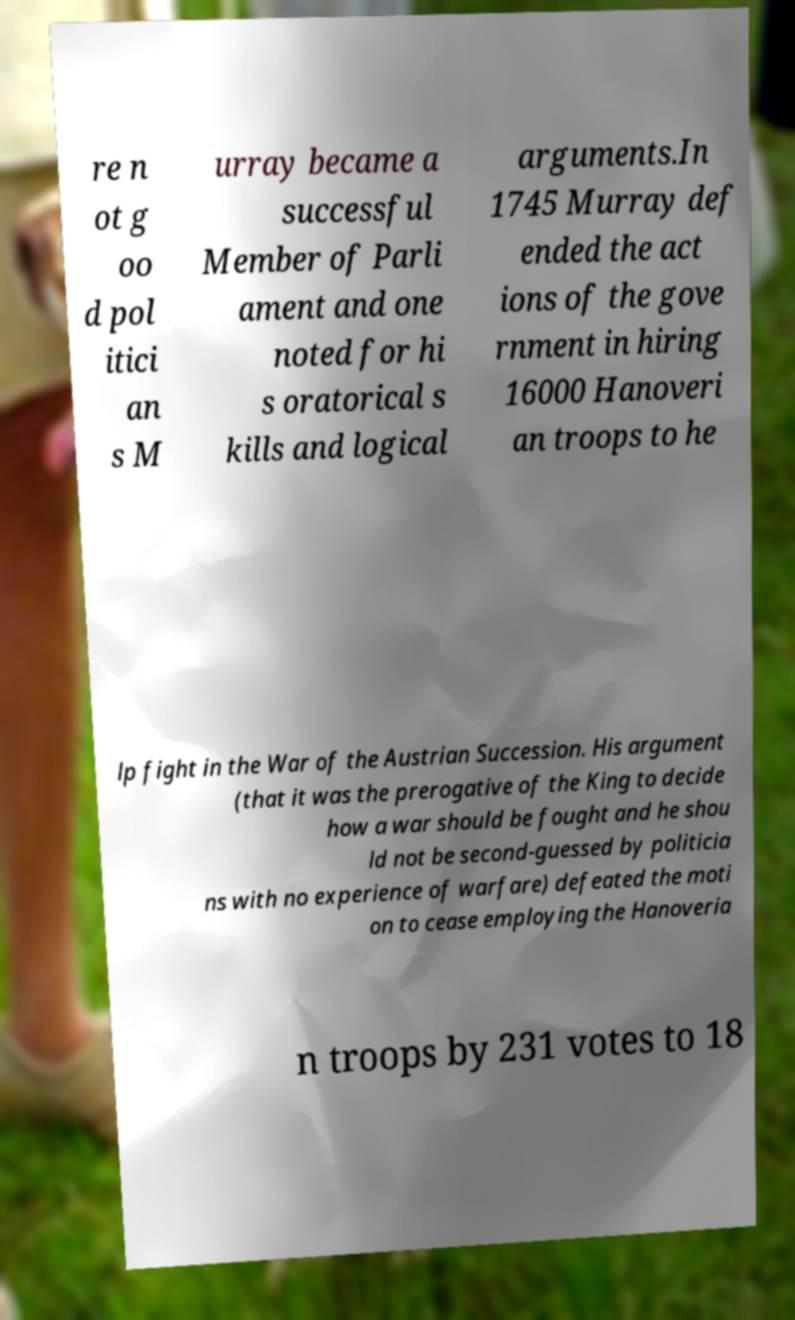There's text embedded in this image that I need extracted. Can you transcribe it verbatim? re n ot g oo d pol itici an s M urray became a successful Member of Parli ament and one noted for hi s oratorical s kills and logical arguments.In 1745 Murray def ended the act ions of the gove rnment in hiring 16000 Hanoveri an troops to he lp fight in the War of the Austrian Succession. His argument (that it was the prerogative of the King to decide how a war should be fought and he shou ld not be second-guessed by politicia ns with no experience of warfare) defeated the moti on to cease employing the Hanoveria n troops by 231 votes to 18 